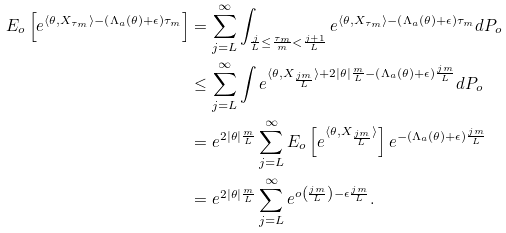Convert formula to latex. <formula><loc_0><loc_0><loc_500><loc_500>E _ { o } \left [ e ^ { \langle \theta , X _ { \tau _ { m } } \rangle - \left ( \Lambda _ { a } ( \theta ) + \epsilon \right ) \tau _ { m } } \right ] & = \sum _ { j = L } ^ { \infty } \int _ { \frac { j } { L } \leq \frac { \tau _ { m } } { m } < \frac { j + 1 } { L } } e ^ { \langle \theta , X _ { \tau _ { m } } \rangle - \left ( \Lambda _ { a } ( \theta ) + \epsilon \right ) \tau _ { m } } d P _ { o } \\ & \leq \sum _ { j = L } ^ { \infty } \int e ^ { \langle \theta , X _ { \frac { j m } { L } } \rangle + 2 | \theta | \frac { m } { L } - \left ( \Lambda _ { a } ( \theta ) + \epsilon \right ) \frac { j m } { L } } d P _ { o } \\ & = e ^ { 2 | \theta | \frac { m } { L } } \sum _ { j = L } ^ { \infty } E _ { o } \left [ e ^ { \langle \theta , X _ { \frac { j m } { L } } \rangle } \right ] e ^ { - \left ( \Lambda _ { a } ( \theta ) + \epsilon \right ) \frac { j m } { L } } \\ & = e ^ { 2 | \theta | \frac { m } { L } } \sum _ { j = L } ^ { \infty } e ^ { o \left ( \frac { j m } { L } \right ) - \epsilon \frac { j m } { L } } .</formula> 